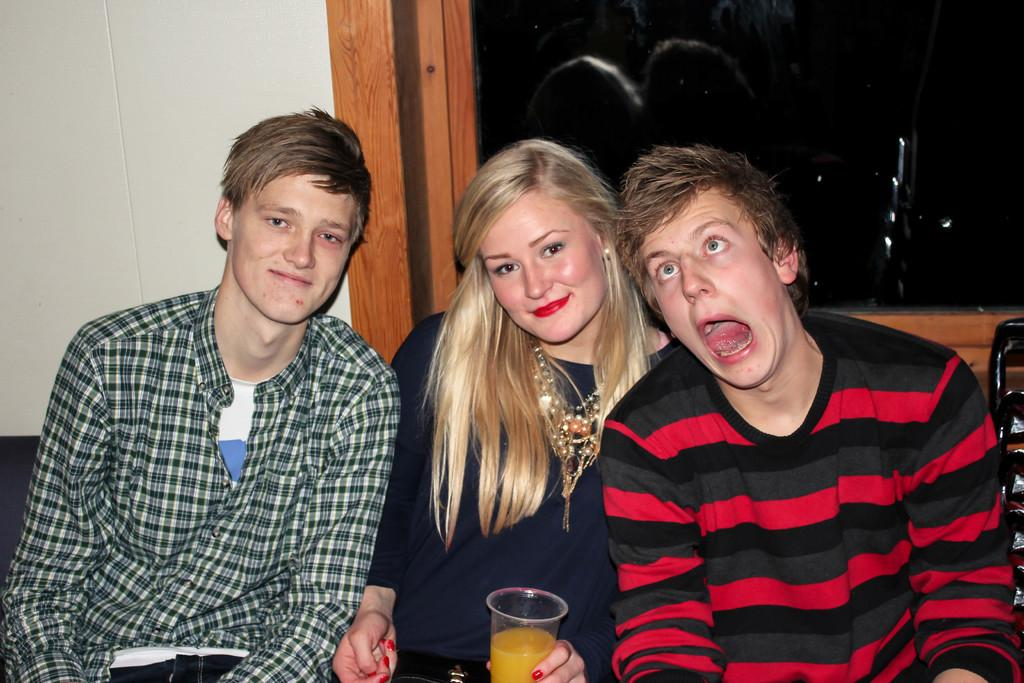How many people are sitting in the image? There are three people sitting in the image. What is one of the people holding? One of the people is holding a glass with a drink. Can you describe the glass visible behind the people? There is a glass visible behind the people, but its contents are not mentioned in the facts. What is located behind the people? There is a wall behind the people. What type of trousers is the person in the middle wearing? The facts provided do not mention the type of trousers the person in the middle is wearing, so we cannot answer this question. 